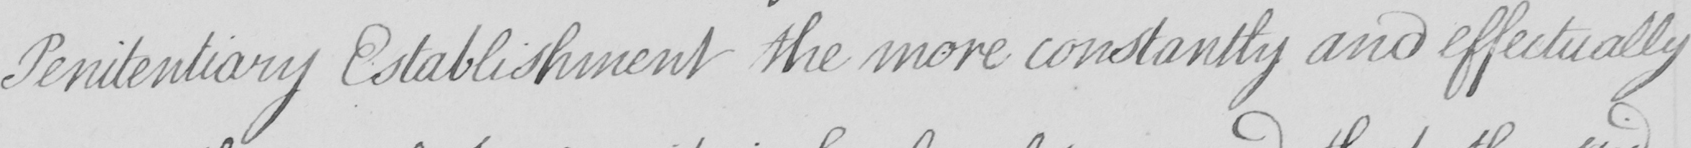What is written in this line of handwriting? Penitentiary Establishment the more constantly and effectually 